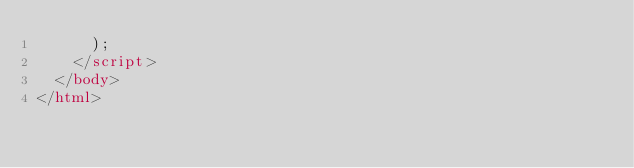Convert code to text. <code><loc_0><loc_0><loc_500><loc_500><_HTML_>      );
    </script>
  </body>
</html>
</code> 